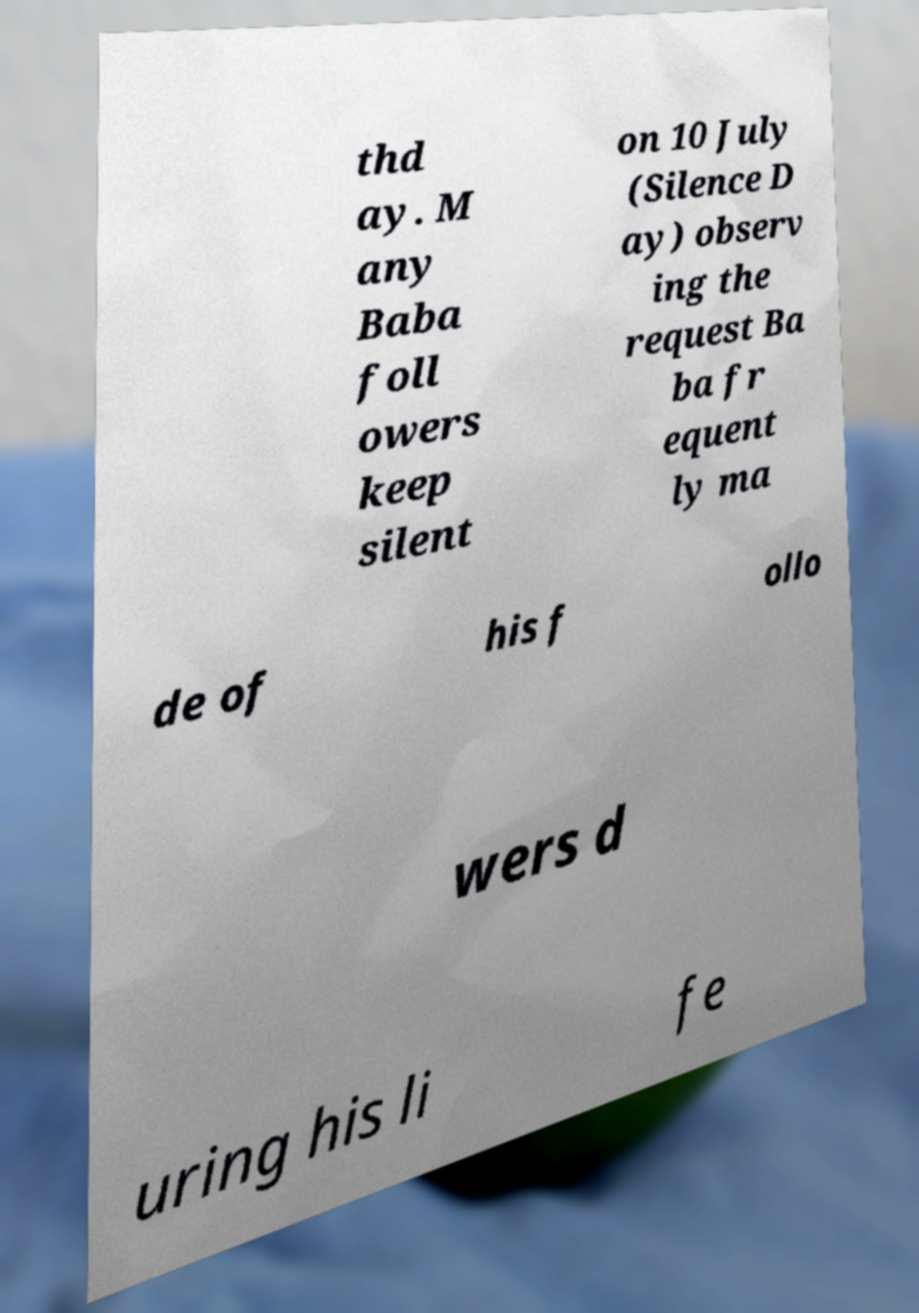Could you extract and type out the text from this image? thd ay. M any Baba foll owers keep silent on 10 July (Silence D ay) observ ing the request Ba ba fr equent ly ma de of his f ollo wers d uring his li fe 